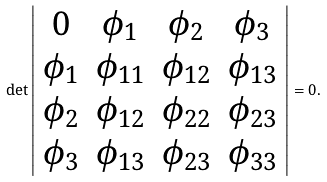<formula> <loc_0><loc_0><loc_500><loc_500>\det \left | \begin{array} { c c c c } 0 & \phi _ { 1 } & \phi _ { 2 } & \phi _ { 3 } \\ \phi _ { 1 } & \phi _ { 1 1 } & \phi _ { 1 2 } & \phi _ { 1 3 } \\ \phi _ { 2 } & \phi _ { 1 2 } & \phi _ { 2 2 } & \phi _ { 2 3 } \\ \phi _ { 3 } & \phi _ { 1 3 } & \phi _ { 2 3 } & \phi _ { 3 3 } \end{array} \right | = 0 .</formula> 